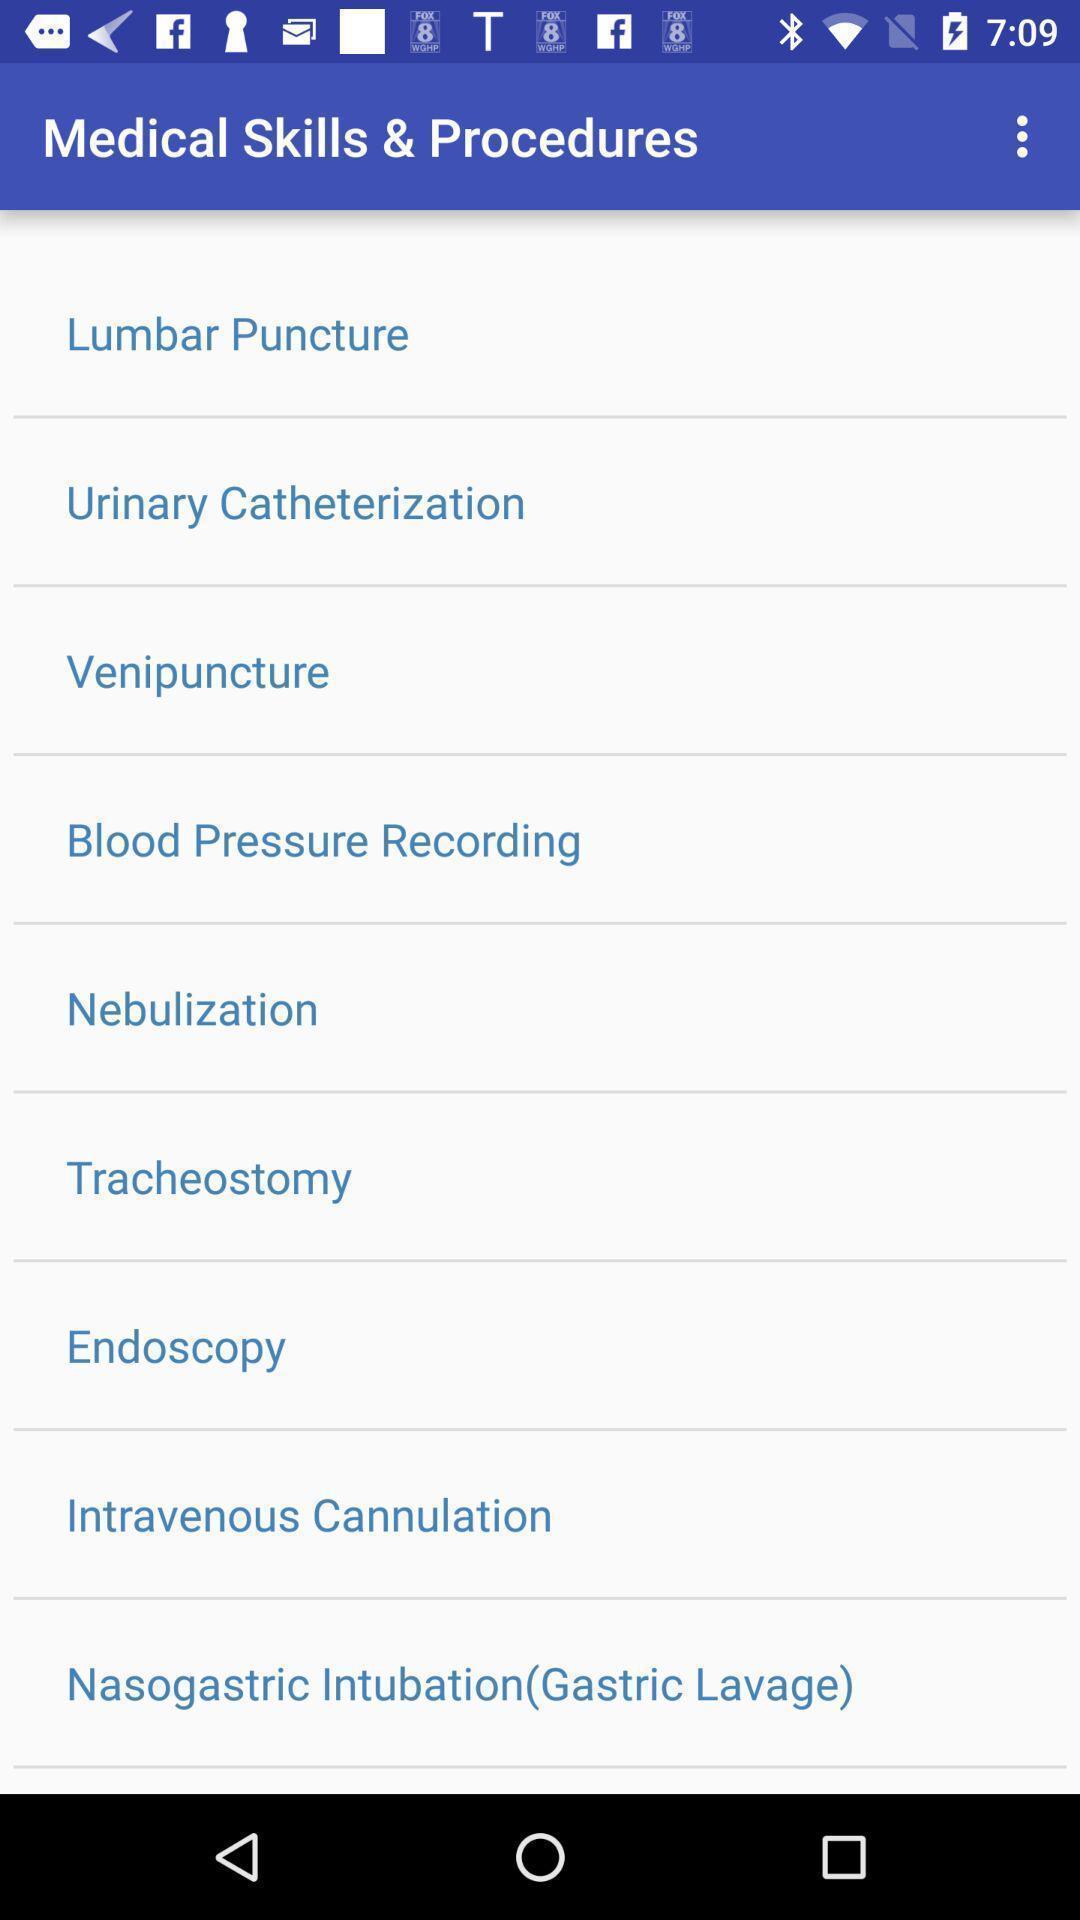Please provide a description for this image. Page displaying the list of medical skills. 